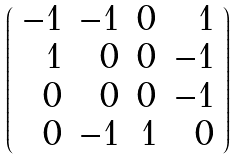Convert formula to latex. <formula><loc_0><loc_0><loc_500><loc_500>\left ( \begin{array} { r r r r } - 1 & - 1 & 0 & 1 \\ 1 & 0 & 0 & - 1 \\ 0 & 0 & 0 & - 1 \\ 0 & - 1 & 1 & 0 \end{array} \right )</formula> 